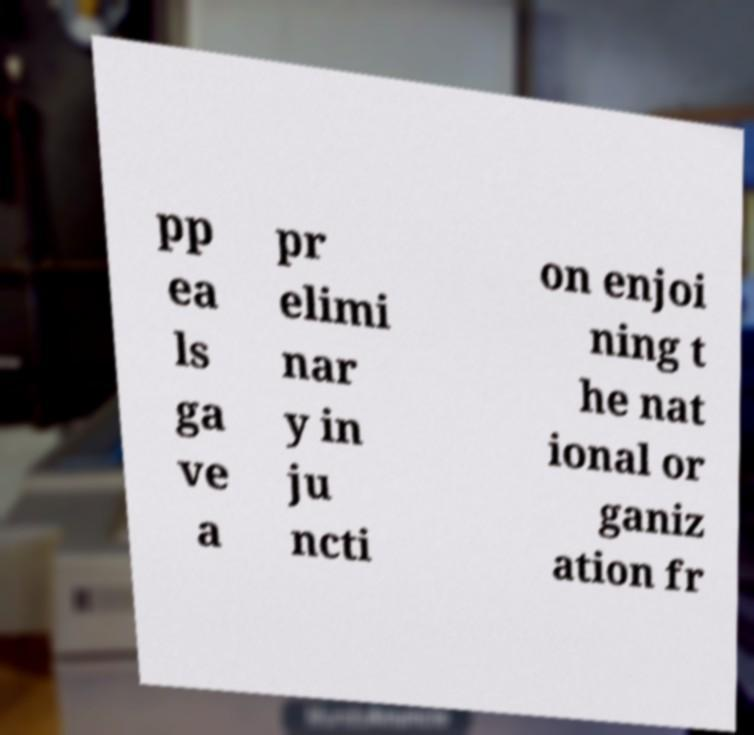Can you read and provide the text displayed in the image?This photo seems to have some interesting text. Can you extract and type it out for me? pp ea ls ga ve a pr elimi nar y in ju ncti on enjoi ning t he nat ional or ganiz ation fr 